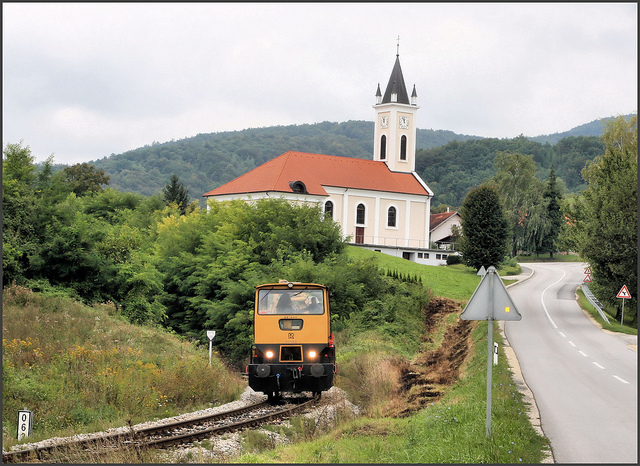Extract all visible text content from this image. 062 